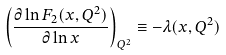<formula> <loc_0><loc_0><loc_500><loc_500>\left ( \frac { \partial \ln F _ { 2 } ( x , Q ^ { 2 } ) } { \partial \ln x } \right ) _ { Q ^ { 2 } } \equiv - \lambda ( x , Q ^ { 2 } )</formula> 